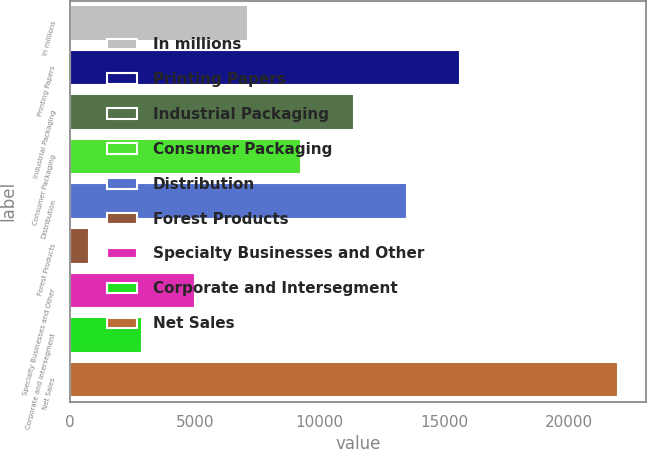Convert chart to OTSL. <chart><loc_0><loc_0><loc_500><loc_500><bar_chart><fcel>In millions<fcel>Printing Papers<fcel>Industrial Packaging<fcel>Consumer Packaging<fcel>Distribution<fcel>Forest Products<fcel>Specialty Businesses and Other<fcel>Corporate and Intersegment<fcel>Net Sales<nl><fcel>7134<fcel>15626<fcel>11380<fcel>9257<fcel>13503<fcel>765<fcel>5011<fcel>2888<fcel>21995<nl></chart> 